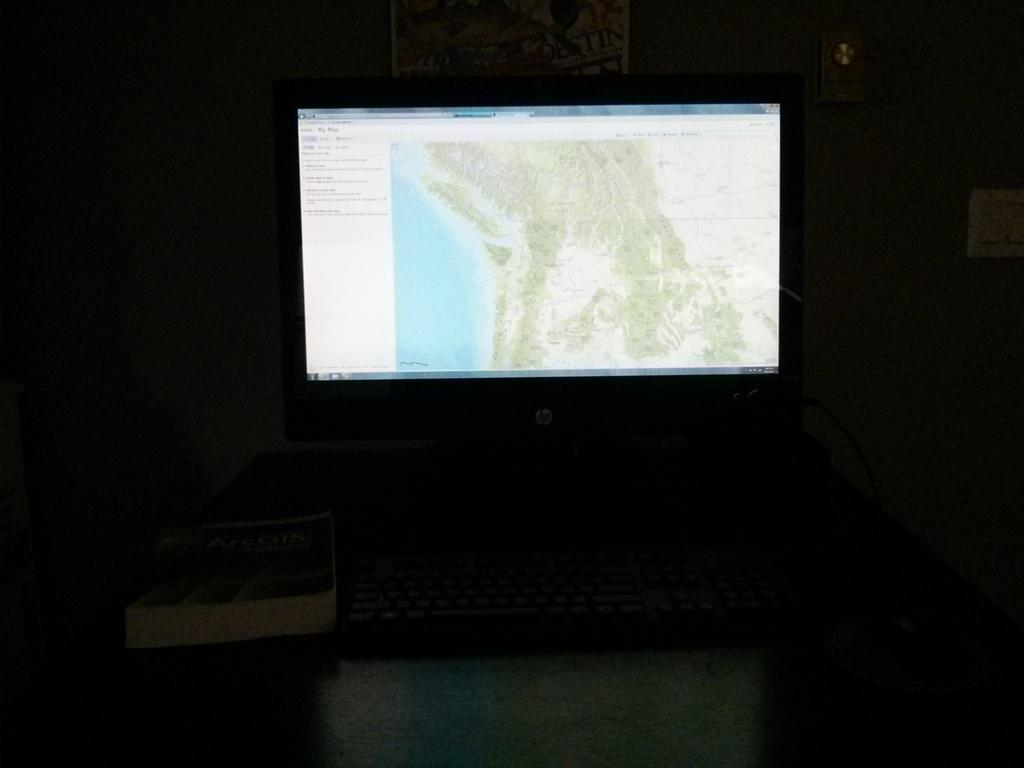What is the main subject of the image? The main subject of the image is a system. Are there any other objects present in the image? Yes, there is a book in the image. What is the color of the background in the image? The background of the image is dark. Can you tell me how many goldfish are swimming in the book in the image? There are no goldfish present in the image, and the book is not a body of water where fish could swim. 